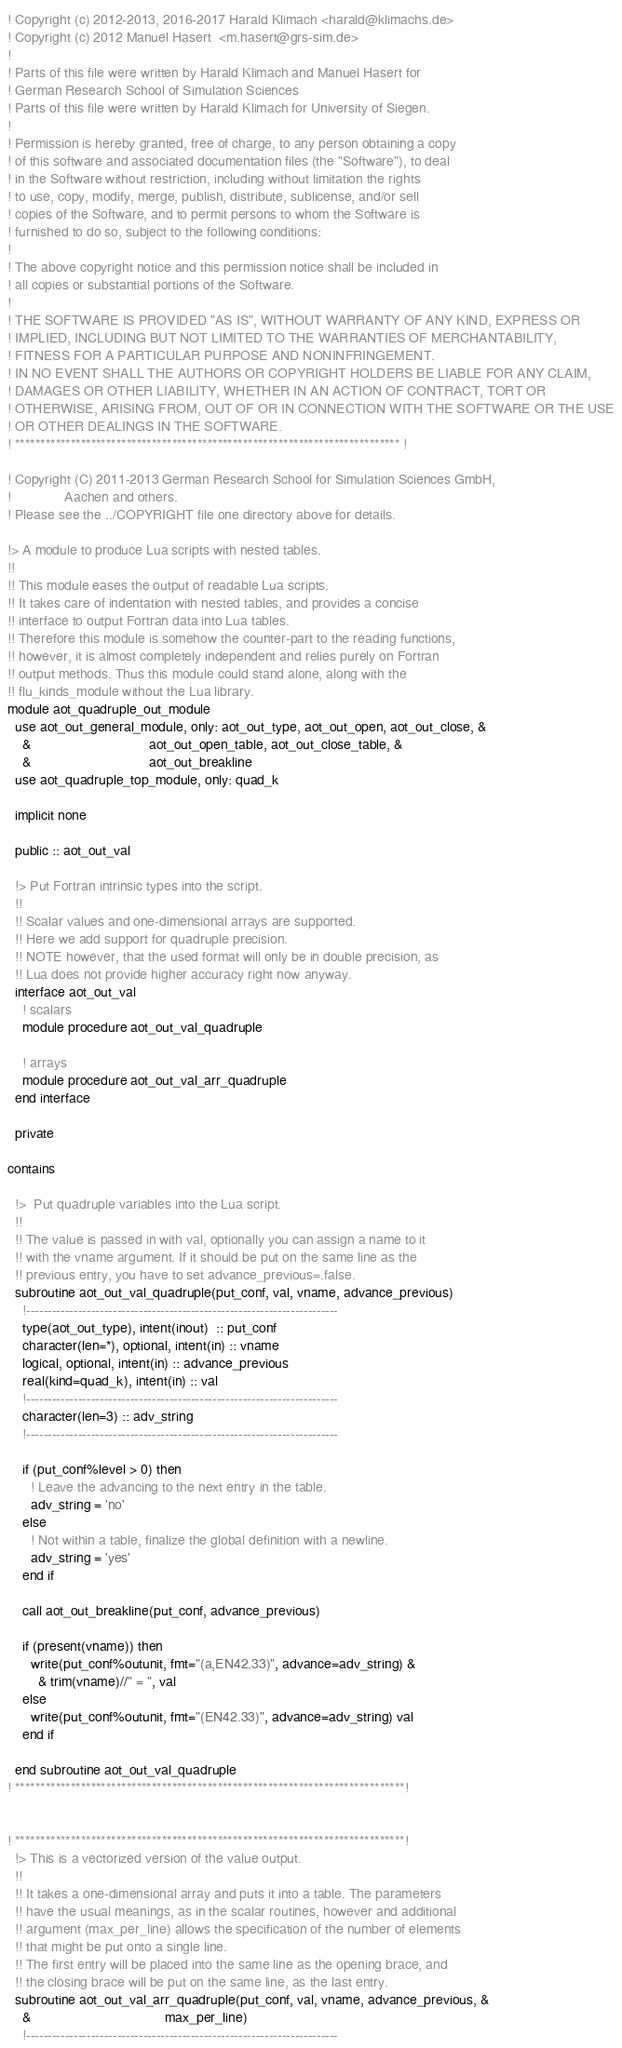Convert code to text. <code><loc_0><loc_0><loc_500><loc_500><_FORTRAN_>! Copyright (c) 2012-2013, 2016-2017 Harald Klimach <harald@klimachs.de>
! Copyright (c) 2012 Manuel Hasert  <m.hasert@grs-sim.de>
!
! Parts of this file were written by Harald Klimach and Manuel Hasert for
! German Research School of Simulation Sciences
! Parts of this file were written by Harald Klimach for University of Siegen.
!
! Permission is hereby granted, free of charge, to any person obtaining a copy
! of this software and associated documentation files (the "Software"), to deal
! in the Software without restriction, including without limitation the rights
! to use, copy, modify, merge, publish, distribute, sublicense, and/or sell
! copies of the Software, and to permit persons to whom the Software is
! furnished to do so, subject to the following conditions:
!
! The above copyright notice and this permission notice shall be included in
! all copies or substantial portions of the Software.
!
! THE SOFTWARE IS PROVIDED "AS IS", WITHOUT WARRANTY OF ANY KIND, EXPRESS OR
! IMPLIED, INCLUDING BUT NOT LIMITED TO THE WARRANTIES OF MERCHANTABILITY,
! FITNESS FOR A PARTICULAR PURPOSE AND NONINFRINGEMENT.
! IN NO EVENT SHALL THE AUTHORS OR COPYRIGHT HOLDERS BE LIABLE FOR ANY CLAIM,
! DAMAGES OR OTHER LIABILITY, WHETHER IN AN ACTION OF CONTRACT, TORT OR
! OTHERWISE, ARISING FROM, OUT OF OR IN CONNECTION WITH THE SOFTWARE OR THE USE
! OR OTHER DEALINGS IN THE SOFTWARE.
! **************************************************************************** !

! Copyright (C) 2011-2013 German Research School for Simulation Sciences GmbH,
!              Aachen and others.
! Please see the ../COPYRIGHT file one directory above for details.

!> A module to produce Lua scripts with nested tables.
!!
!! This module eases the output of readable Lua scripts.
!! It takes care of indentation with nested tables, and provides a concise
!! interface to output Fortran data into Lua tables.
!! Therefore this module is somehow the counter-part to the reading functions,
!! however, it is almost completely independent and relies purely on Fortran
!! output methods. Thus this module could stand alone, along with the
!! flu_kinds_module without the Lua library.
module aot_quadruple_out_module
  use aot_out_general_module, only: aot_out_type, aot_out_open, aot_out_close, &
    &                               aot_out_open_table, aot_out_close_table, &
    &                               aot_out_breakline
  use aot_quadruple_top_module, only: quad_k

  implicit none

  public :: aot_out_val

  !> Put Fortran intrinsic types into the script.
  !!
  !! Scalar values and one-dimensional arrays are supported.
  !! Here we add support for quadruple precision.
  !! NOTE however, that the used format will only be in double precision, as
  !! Lua does not provide higher accuracy right now anyway.
  interface aot_out_val
    ! scalars
    module procedure aot_out_val_quadruple

    ! arrays
    module procedure aot_out_val_arr_quadruple
  end interface

  private

contains

  !>  Put quadruple variables into the Lua script.
  !!
  !! The value is passed in with val, optionally you can assign a name to it
  !! with the vname argument. If it should be put on the same line as the
  !! previous entry, you have to set advance_previous=.false.
  subroutine aot_out_val_quadruple(put_conf, val, vname, advance_previous)
    !------------------------------------------------------------------------
    type(aot_out_type), intent(inout)  :: put_conf
    character(len=*), optional, intent(in) :: vname
    logical, optional, intent(in) :: advance_previous
    real(kind=quad_k), intent(in) :: val
    !------------------------------------------------------------------------
    character(len=3) :: adv_string
    !------------------------------------------------------------------------

    if (put_conf%level > 0) then
      ! Leave the advancing to the next entry in the table.
      adv_string = 'no'
    else
      ! Not within a table, finalize the global definition with a newline.
      adv_string = 'yes'
    end if

    call aot_out_breakline(put_conf, advance_previous)

    if (present(vname)) then
      write(put_conf%outunit, fmt="(a,EN42.33)", advance=adv_string) &
        & trim(vname)//" = ", val
    else
      write(put_conf%outunit, fmt="(EN42.33)", advance=adv_string) val
    end if

  end subroutine aot_out_val_quadruple
! *****************************************************************************!


! *****************************************************************************!
  !> This is a vectorized version of the value output.
  !!
  !! It takes a one-dimensional array and puts it into a table. The parameters
  !! have the usual meanings, as in the scalar routines, however and additional
  !! argument (max_per_line) allows the specification of the number of elements
  !! that might be put onto a single line.
  !! The first entry will be placed into the same line as the opening brace, and
  !! the closing brace will be put on the same line, as the last entry.
  subroutine aot_out_val_arr_quadruple(put_conf, val, vname, advance_previous, &
    &                                   max_per_line)
    !------------------------------------------------------------------------</code> 